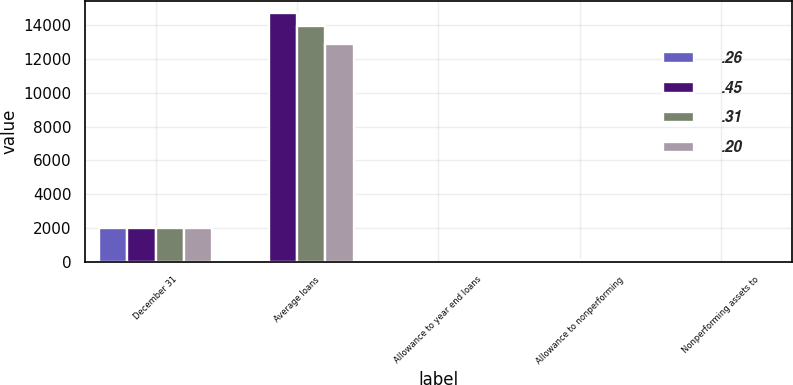<chart> <loc_0><loc_0><loc_500><loc_500><stacked_bar_chart><ecel><fcel>December 31<fcel>Average loans<fcel>Allowance to year end loans<fcel>Allowance to nonperforming<fcel>Nonperforming assets to<nl><fcel>0.26<fcel>2017<fcel>101<fcel>0.16<fcel>93<fcel>0.2<nl><fcel>0.45<fcel>2016<fcel>14715<fcel>0.17<fcel>101<fcel>0.21<nl><fcel>0.31<fcel>2015<fcel>13973<fcel>0.21<fcel>110<fcel>0.26<nl><fcel>0.2<fcel>2014<fcel>12906<fcel>0.31<fcel>120<fcel>0.31<nl></chart> 